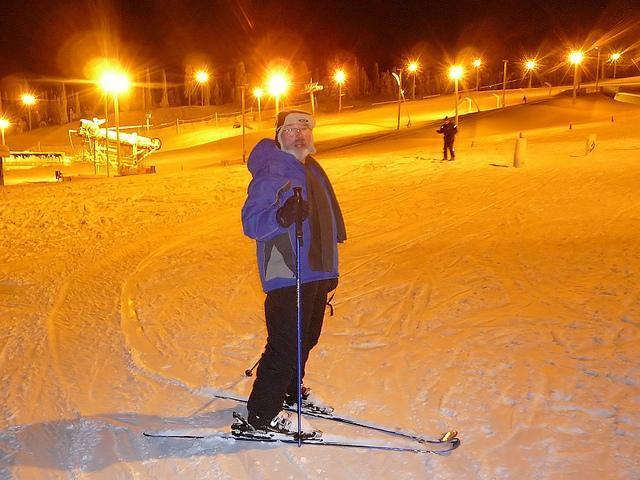How many people are in this picture?
Give a very brief answer. 2. How many people can you see?
Give a very brief answer. 1. How many ski are there?
Give a very brief answer. 1. 